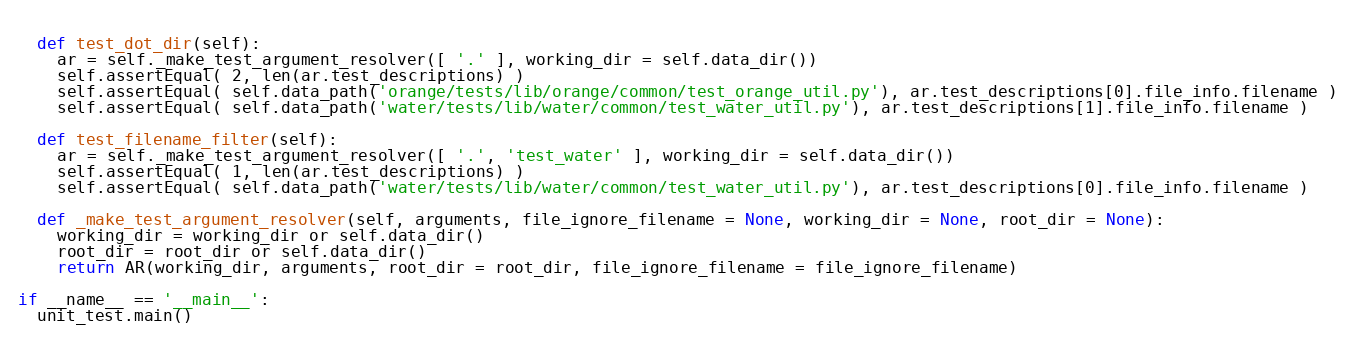<code> <loc_0><loc_0><loc_500><loc_500><_Python_>    
  def test_dot_dir(self):
    ar = self._make_test_argument_resolver([ '.' ], working_dir = self.data_dir())
    self.assertEqual( 2, len(ar.test_descriptions) )
    self.assertEqual( self.data_path('orange/tests/lib/orange/common/test_orange_util.py'), ar.test_descriptions[0].file_info.filename )
    self.assertEqual( self.data_path('water/tests/lib/water/common/test_water_util.py'), ar.test_descriptions[1].file_info.filename )
    
  def test_filename_filter(self):
    ar = self._make_test_argument_resolver([ '.', 'test_water' ], working_dir = self.data_dir())
    self.assertEqual( 1, len(ar.test_descriptions) )
    self.assertEqual( self.data_path('water/tests/lib/water/common/test_water_util.py'), ar.test_descriptions[0].file_info.filename )
    
  def _make_test_argument_resolver(self, arguments, file_ignore_filename = None, working_dir = None, root_dir = None):
    working_dir = working_dir or self.data_dir()
    root_dir = root_dir or self.data_dir()
    return AR(working_dir, arguments, root_dir = root_dir, file_ignore_filename = file_ignore_filename)

if __name__ == '__main__':
  unit_test.main()
    
</code> 